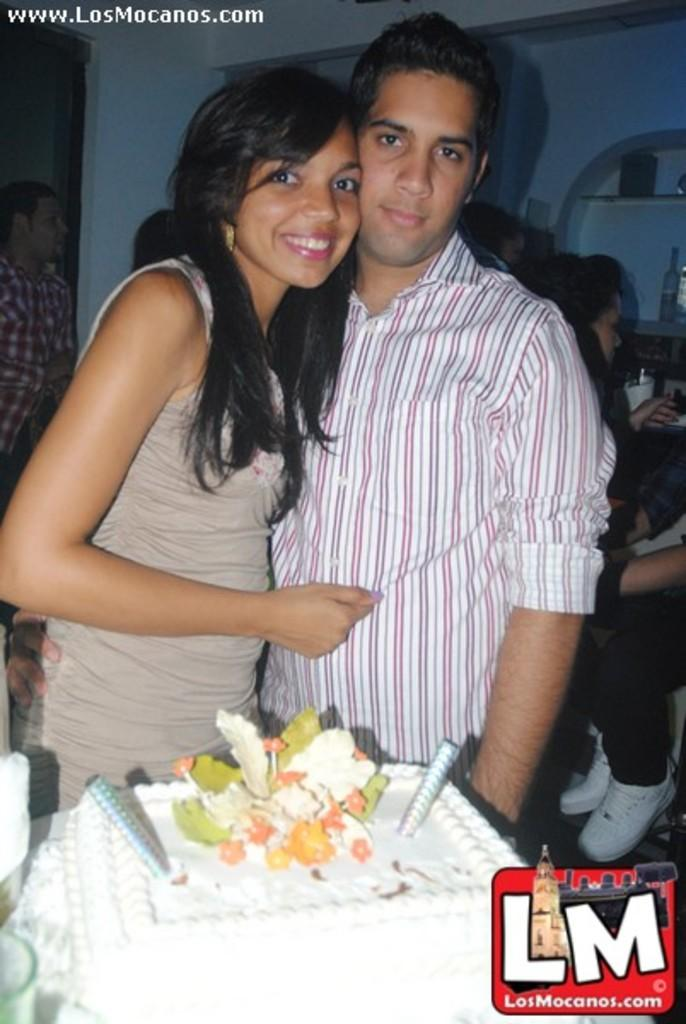Who or what can be seen in the image? There are people in the image. What type of food is present in the image? There is a white-colored cake in the image. Is there any text or logo visible in the image? Yes, there is a watermark in the image. How is the mood of one of the people in the image? A person in the image has a smile on their face. What can be seen in the background of the image? There are racks visible in the background of the image. What type of jail can be seen in the image? There is no jail present in the image. Is there a quill used for writing in the image? There is no quill visible in the image. 